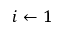Convert formula to latex. <formula><loc_0><loc_0><loc_500><loc_500>i \gets 1</formula> 